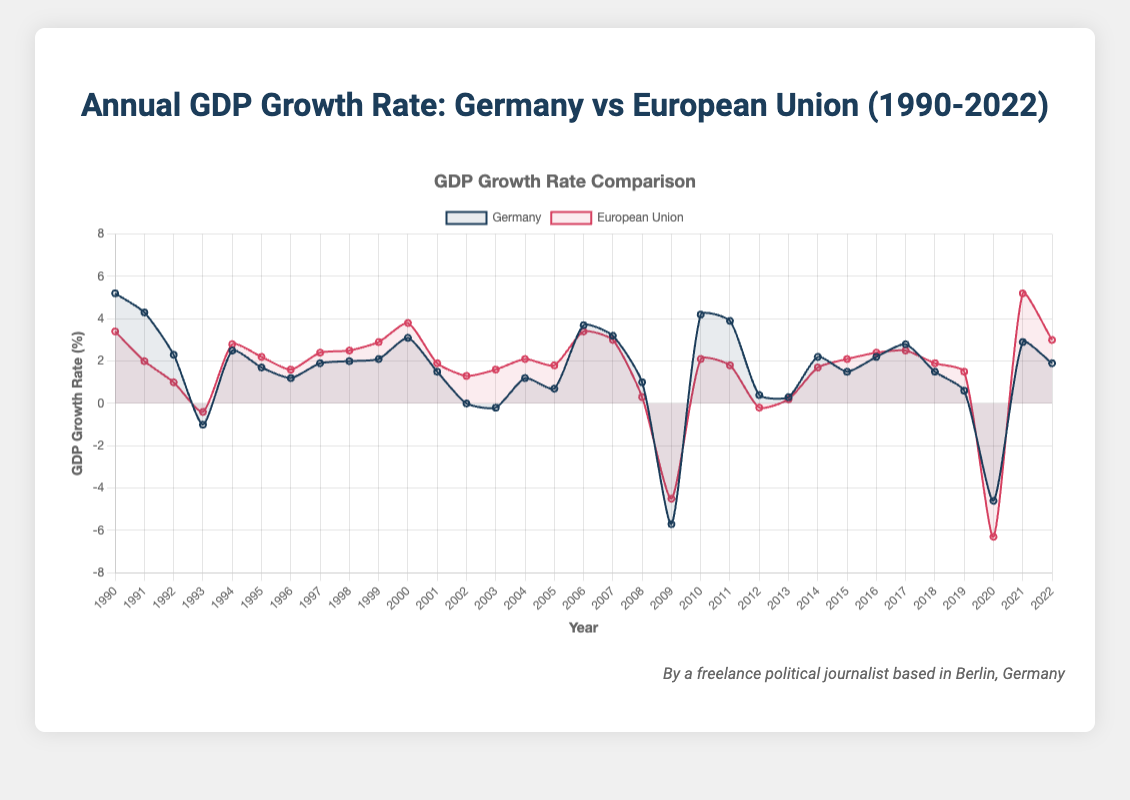How does the GDP growth rate of Germany compare to the European Union in 2020? The chart shows that in 2020, Germany had a GDP growth rate of -4.6%, while the European Union had a GDP growth rate of -6.3%. Comparing these two values, Germany's GDP growth rate was higher than the European Union's by 1.7%.
Answer: Germany's rate was higher Over which periods did Germany experience a negative GDP growth rate? By examining the chart, Germany experienced negative GDP growth rates in the following years: 1993, 2003, 2009, 2012, and 2020. These are the periods where the line representing Germany dips below the 0% line.
Answer: 1993, 2003, 2009, 2012, 2020 When did the European Union experience its most severe GDP decline, and what was the value? The chart indicates the most severe decline for the European Union occurred in 2020, where the GDP growth rate fell to -6.3%. This is the lowest point on the line representing the European Union.
Answer: 2020, -6.3% What is the average GDP growth rate for Germany from 2000 to 2010? For the given period (2000 - 2010), we take the values for Germany: 3.1, 1.5, 0.0, -0.2, 1.2, 0.7, 3.7, 3.2, 1.0, -5.7, 4.2. Summing these values gives 13.7, and there are 11 data points, so the average is 13.7 / 11 = 1.245.
Answer: 1.245% In which year did both Germany and the European Union have the same or nearly the same GDP growth rate, and what was the value? According to the chart, in 1996, both Germany and the European Union had nearly identical growth rates of 1.2% and 1.6%, respectively, which appear almost equal as per the visual representation.
Answer: 1996, approximately 1.6% How did German GDP growth in 2009 compare to the European Union's growth in the same year? In 2009, Germany's GDP growth rate was -5.7%, while the European Union's growth rate was -4.5%. Germany's decline was 1.2% greater than the European Union's decline in that year.
Answer: Germany's decline was 1.2% greater Between which two years did Germany have the largest annual increase in GDP growth rate, and what was the increment? The largest annual increase for Germany is between 2009 (-5.7%) and 2010 (4.2%), with a difference of 4.2 - (-5.7) = 9.9%. This is the largest positive change visible in the chart for Germany.
Answer: Between 2009 and 2010, 9.9% Which country had a higher GDP growth rate during the global financial crisis of 2008-2009, and what were their respective rates? In 2008, Germany's GDP growth rate was 1.0%, and in 2009 it was -5.7%. For the European Union, the rates were 0.3% in 2008 and -4.5% in 2009. During both years, the European Union had a slightly better (less negative) growth rate compared to Germany.
Answer: European Union, 0.3% (2008), -4.5% (2009) Comparing the recovery after 2009, which entity showed a more significant recovery in terms of GDP growth rate by 2010? By 2010, Germany's GDP growth recovered to 4.2%, and the European Union's growth rate was 2.1%. Germany experienced a more significant recovery, as its GDP growth rate increased by 9.9% (from -5.7% to 4.2%), compared to the European Union's increase of 6.6% (from -4.5% to 2.1%).
Answer: Germany Which entity, Germany or the European Union, had more stable GDP growth rates from 1990 to 2022? Reviewing the chart, the European Union generally shows less volatility and smoother transitions in its GDP growth rate, whereas Germany's growth rates fluctuate more significantly, indicating that the European Union had more stable GDP growth rates over the period.
Answer: European Union 